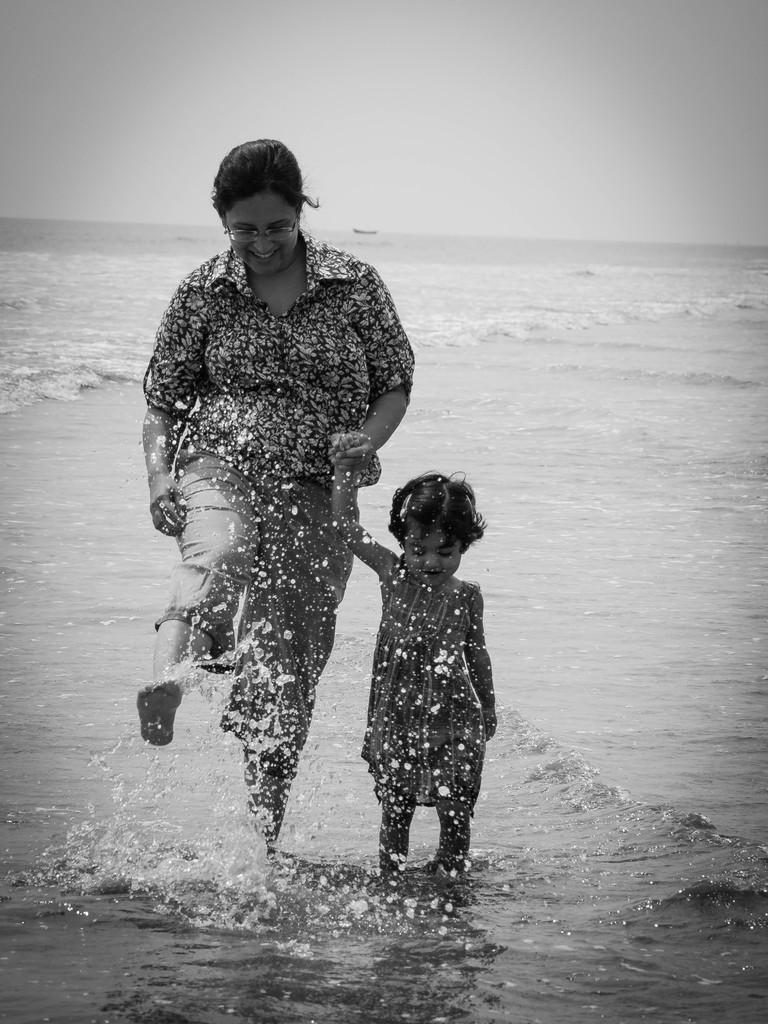In one or two sentences, can you explain what this image depicts? This is a black and white image of lady and girl playing in the beach. 